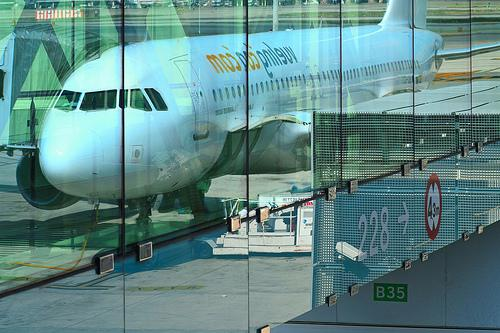Express the sentiment conveyed by the image. The image conveys a sense of orderliness and preparation, as a white passenger plane is parked and ready for boarding on an airport tarmac. What is the most noticeable object in the picture? List any text or symbols found on it. The most noticeable object is a white airplane on the runway, featuring the white number "228", a red circle sign, and an airline logo in orange and grey. Identify the primary object and color in the image and describe its surroundings. The primary object is a white airplane on the runway, surrounded by features like dark windows, a red and white sign, large windows, an engine, a logo, and multiple other descriptive elements. Count the number of windows visible on the left side of the plane. There are a row of windows along the plane's side, totaling approximately 47 windows on the left side. What are some notable features near the airplane on the ground? There are large windows looking outside, a white camera on the wall, a sign pointing to a gate, and a tarmac for the airport near the airplane on the ground. Express the overall content of the image in a single sentence. The image is of a large white airplane parked on a runway, with various structural details like windows, doors, and logos visible. How would you describe the plane's overall color and any marks or writing on its exterior? The plane is mostly white in color, with yellow and gray writing, white number "228", a red circle, and an orange and grey logo on its exterior. 